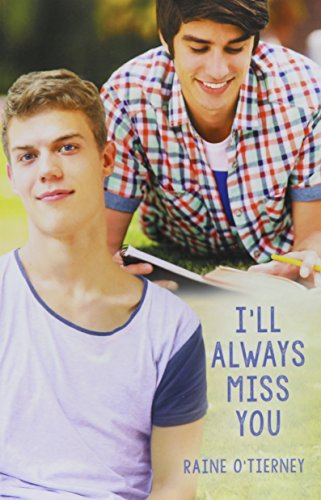What is the title of this book? The title displayed on the book's cover is 'I'll Always Miss You'. 